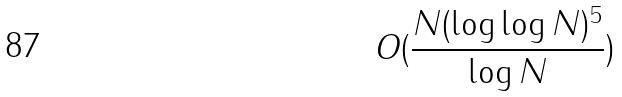Convert formula to latex. <formula><loc_0><loc_0><loc_500><loc_500>O ( \frac { N ( \log \log N ) ^ { 5 } } { \log N } )</formula> 